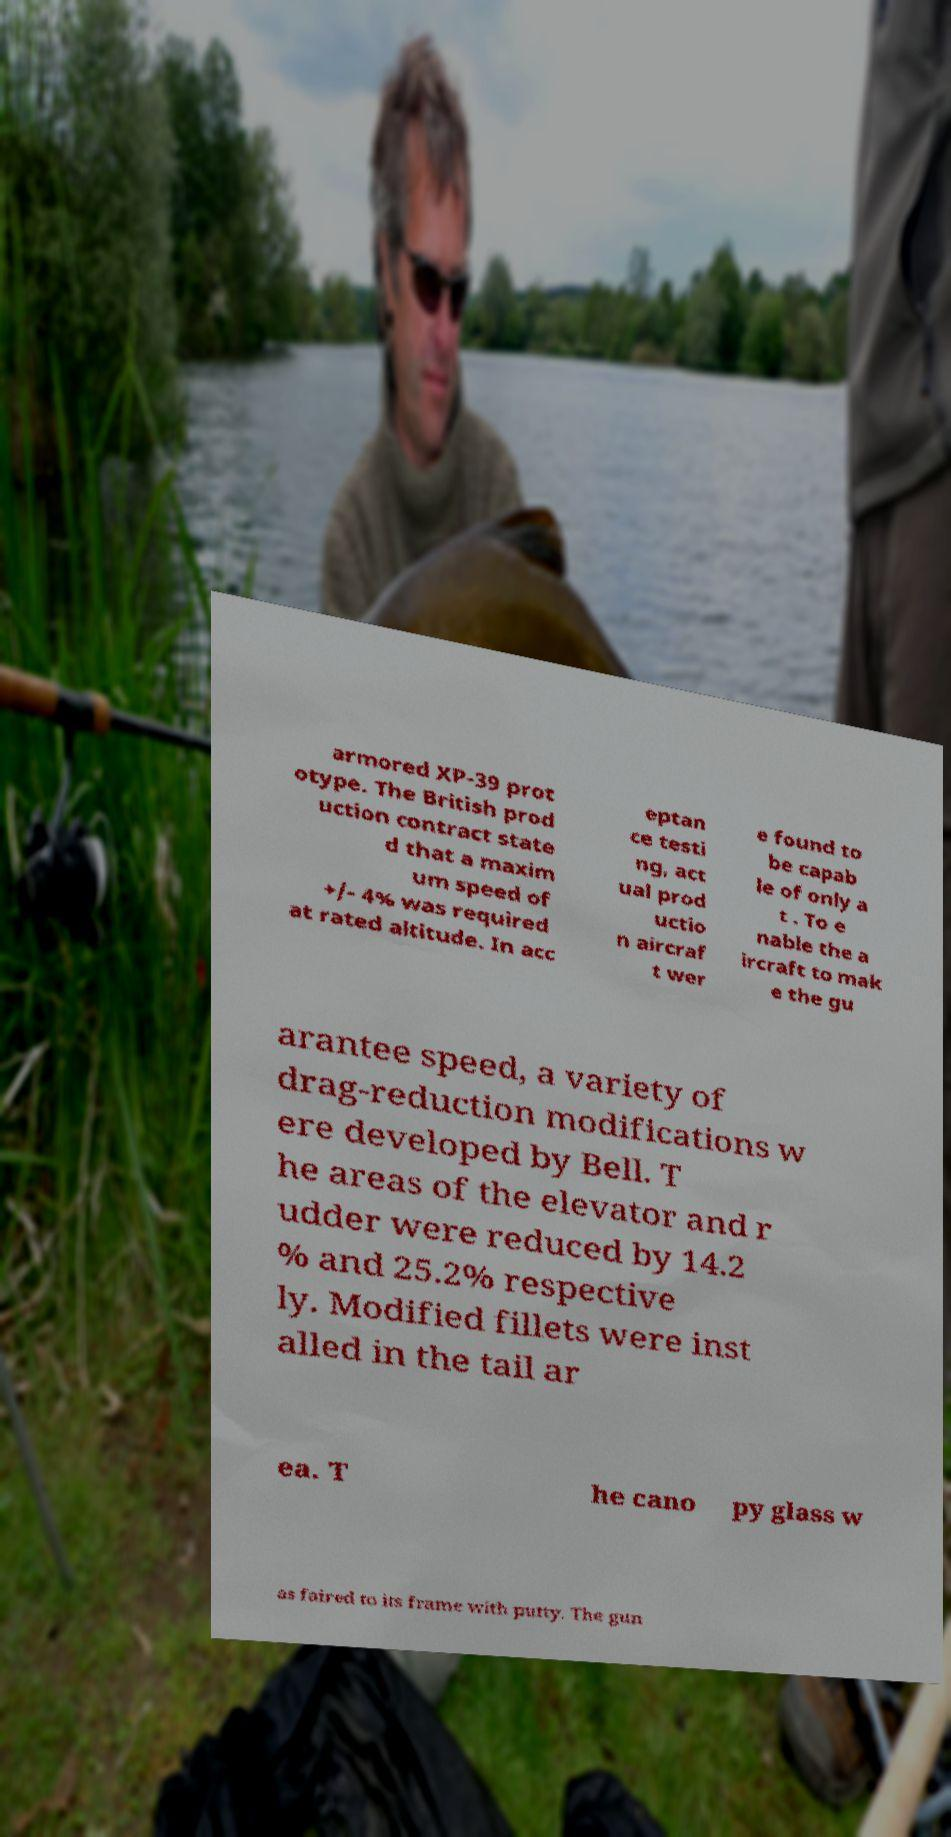Can you accurately transcribe the text from the provided image for me? armored XP-39 prot otype. The British prod uction contract state d that a maxim um speed of +/- 4% was required at rated altitude. In acc eptan ce testi ng, act ual prod uctio n aircraf t wer e found to be capab le of only a t . To e nable the a ircraft to mak e the gu arantee speed, a variety of drag-reduction modifications w ere developed by Bell. T he areas of the elevator and r udder were reduced by 14.2 % and 25.2% respective ly. Modified fillets were inst alled in the tail ar ea. T he cano py glass w as faired to its frame with putty. The gun 